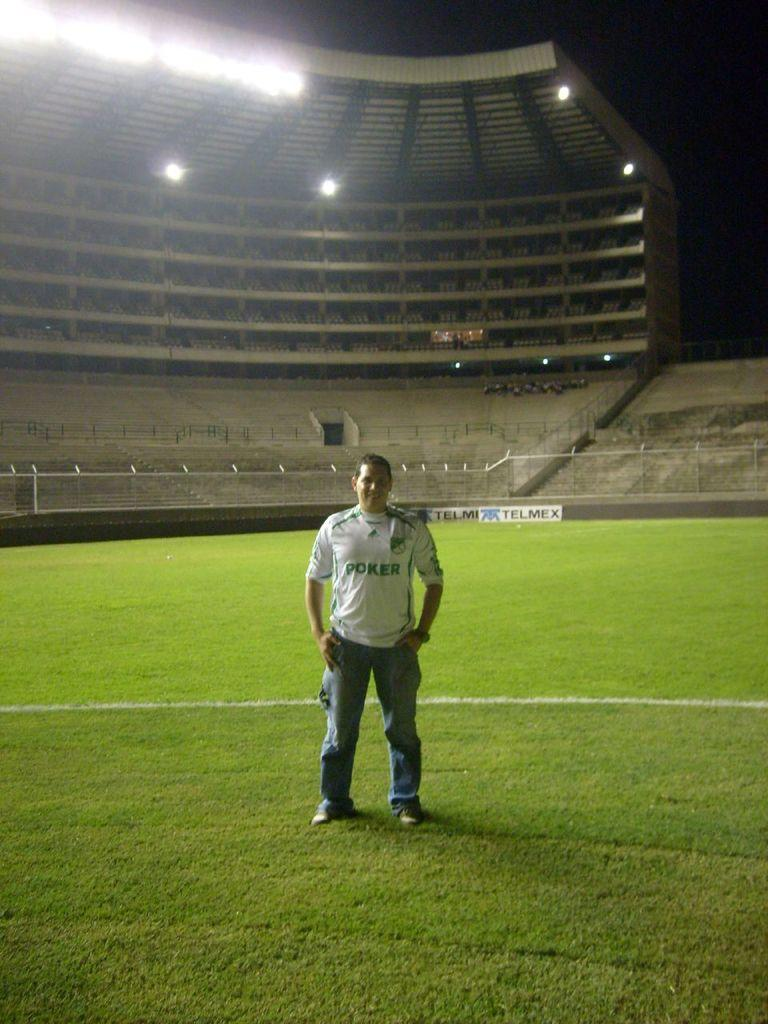<image>
Summarize the visual content of the image. A man standing on the field with a shirt that says poker 